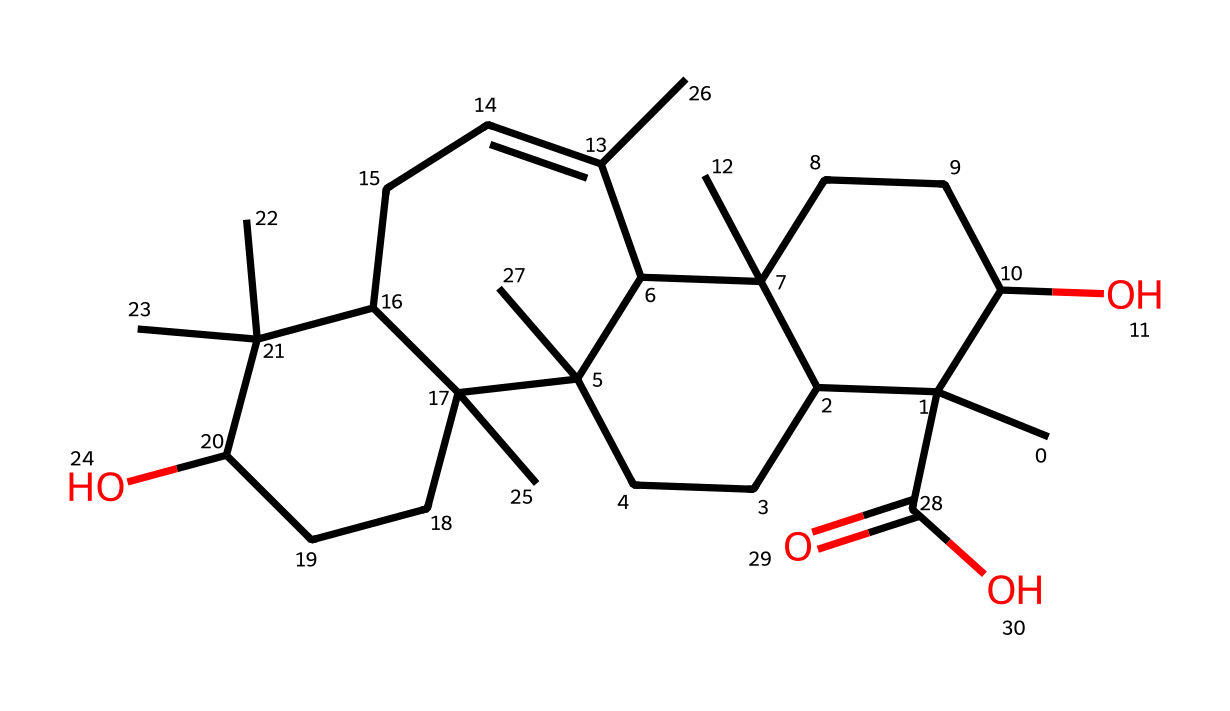What is the molecular formula of boswellic acid? To determine the molecular formula, count the number of each type of atom present in the structure. There are 30 carbon atoms (C), 50 hydrogen atoms (H), and 4 oxygen atoms (O). Therefore, the molecular formula is C30H50O4.
Answer: C30H50O4 How many rings are present in the structure of boswellic acid? By analyzing the structure, there are two fused cyclohexane rings that are visible. These rings make the compound a triterpene, which is characterized by a three-ring structure.
Answer: 2 What functional groups are present in boswellic acid? The structure shows the presence of hydroxyl groups (-OH) and a carboxylic acid group (-COOH). These groups are indicative of the compound's biochemical activity.
Answer: hydroxyl and carboxylic acid groups Which part of the boswellic acid structure is responsible for its anti-inflammatory properties? The boswellic acid has a specific arrangement of functional groups and a particular steric configuration which contributes to its ability to inhibit pro-inflammatory pathways; thus, the molecular structure as a whole contributes to these properties.
Answer: entire structure How many stereocenters are in boswellic acid? A stereocenter in a molecule is typically a carbon atom that has four different substituents attached. By examining the structure, there are several chiral centers, and in this case, there are 3 stereocenters.
Answer: 3 